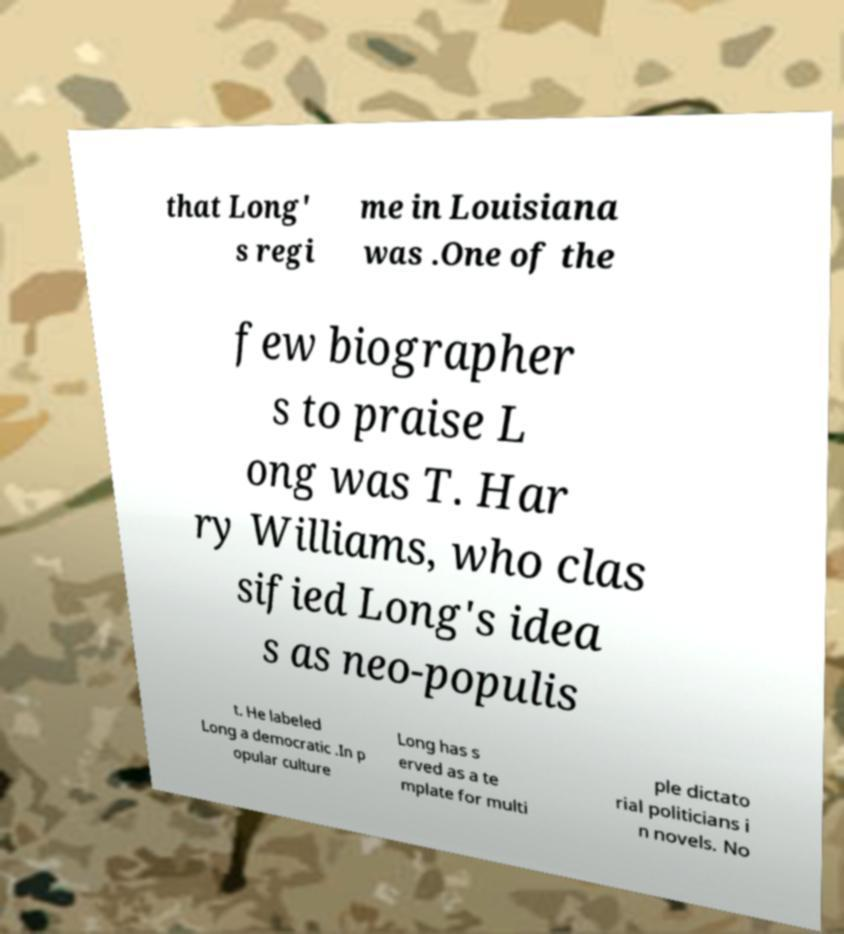What messages or text are displayed in this image? I need them in a readable, typed format. that Long' s regi me in Louisiana was .One of the few biographer s to praise L ong was T. Har ry Williams, who clas sified Long's idea s as neo-populis t. He labeled Long a democratic .In p opular culture Long has s erved as a te mplate for multi ple dictato rial politicians i n novels. No 